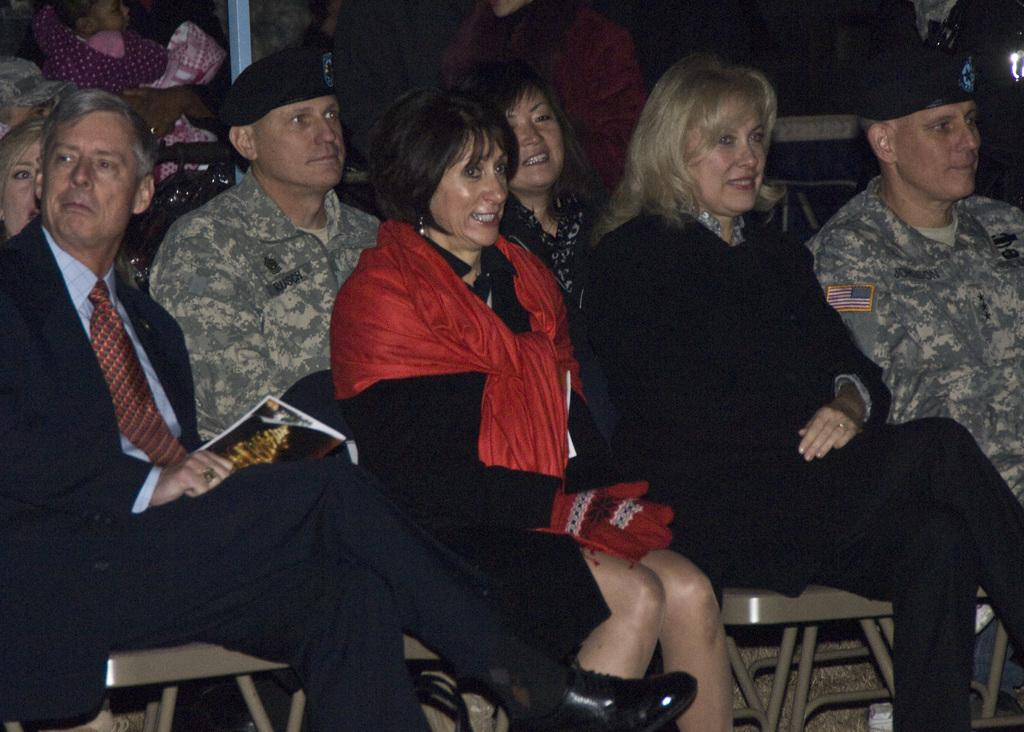What type of individuals can be seen in the picture? There are soldiers in the picture. Are there any civilians present in the image? Yes, there are people sitting in the picture. What is the emotional state of the women in the first two rows? The women in the first two rows are laughing. Can you describe the arrangement of people in the image? There are other people behind the women in the first two rows. What type of plantation can be seen in the background of the image? There is no plantation present in the image; it features soldiers and people sitting. Can you tell me how many thumbs are visible in the image? It is not possible to determine the number of thumbs visible in the image, as the focus is on the people and their actions, not their body parts. 